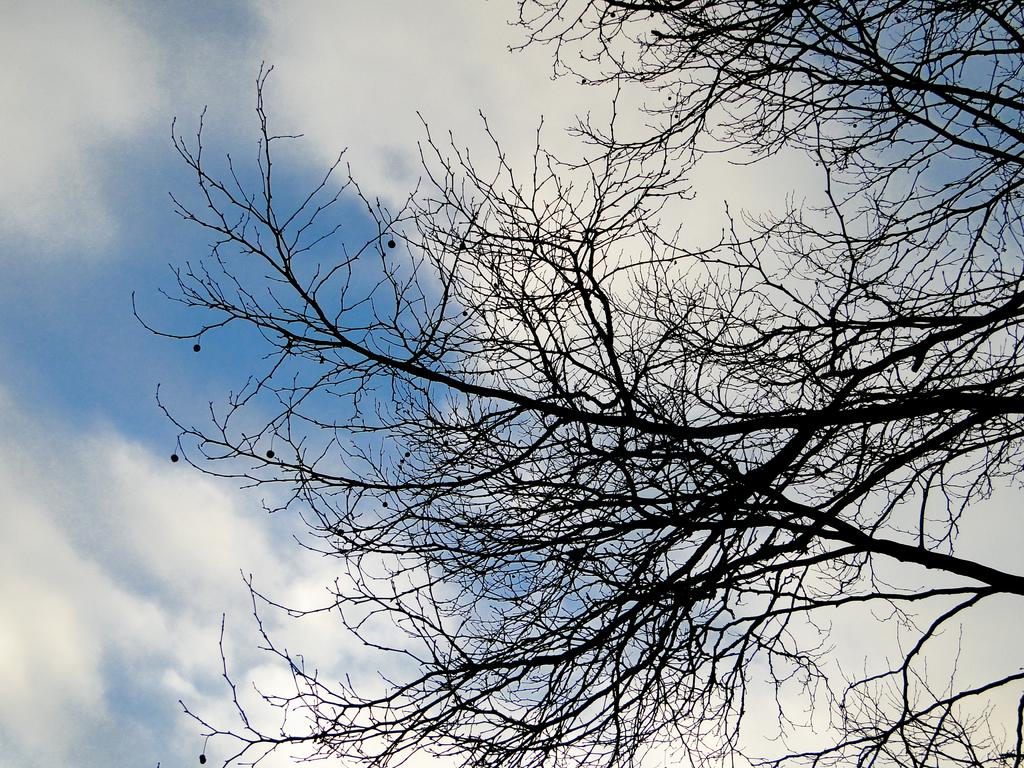What type of vegetation is on the right side of the image? There are trees on the right side of the image. What can be seen in the background of the image? There are clouds in the background of the image. What color is the sky in the image? The sky is blue in the image. Where is the oven located in the image? There is no oven present in the image. What type of reaction is taking place between the clouds and the sky in the image? There is no reaction between the clouds and the sky in the image; they are simply visible in the background. 